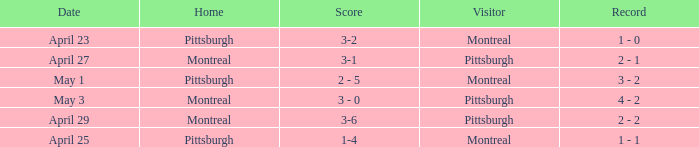What was the score on April 25? 1-4. 